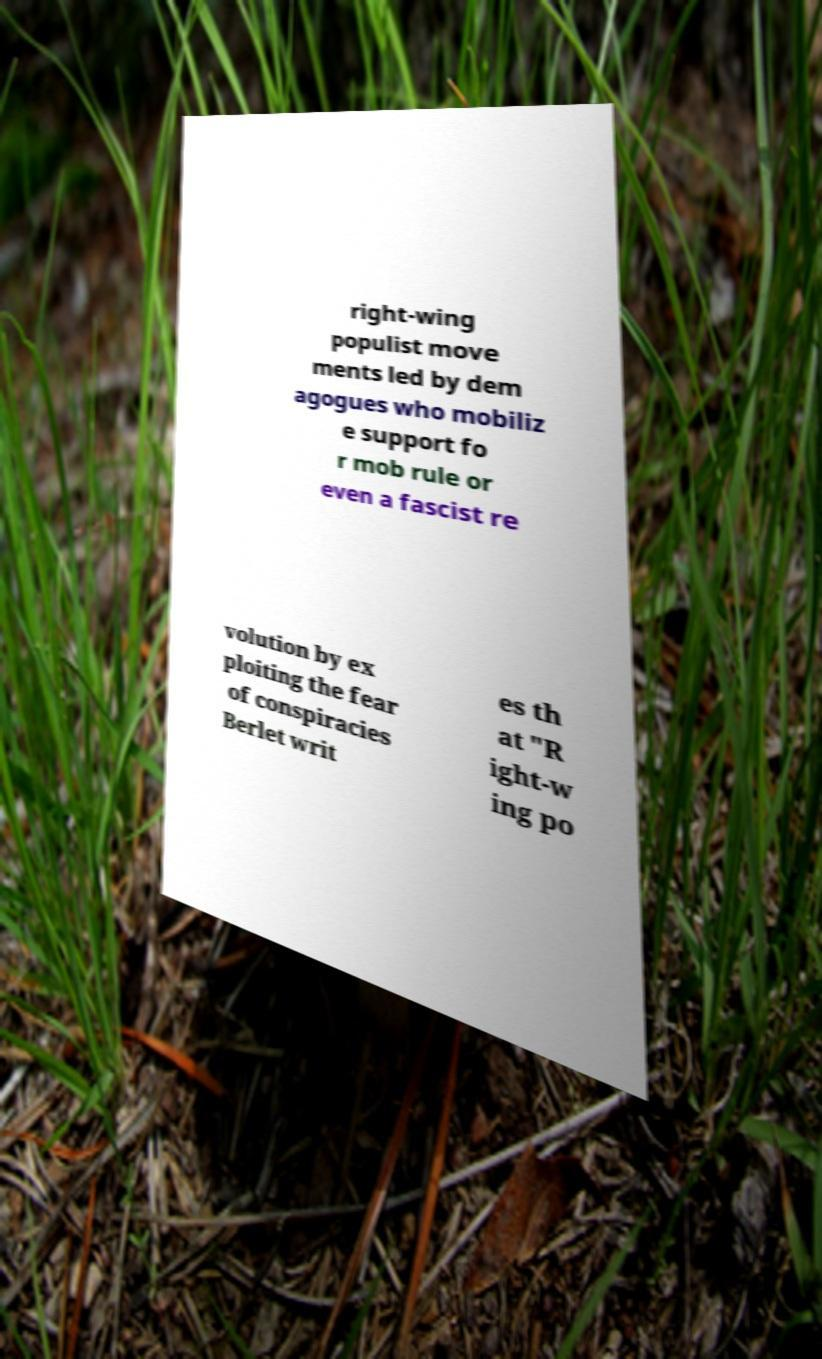For documentation purposes, I need the text within this image transcribed. Could you provide that? right-wing populist move ments led by dem agogues who mobiliz e support fo r mob rule or even a fascist re volution by ex ploiting the fear of conspiracies Berlet writ es th at "R ight-w ing po 